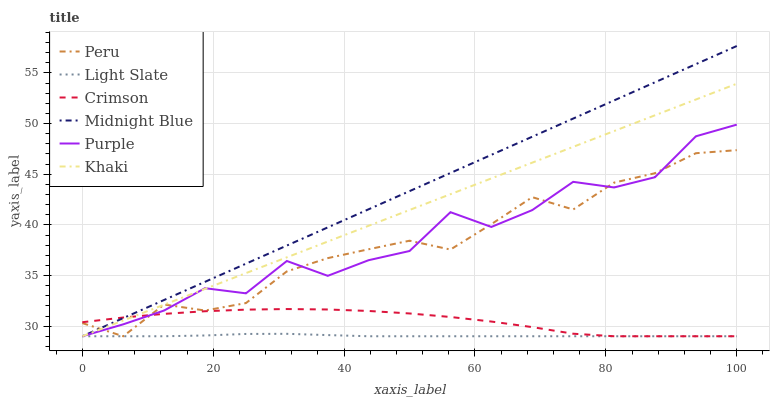Does Light Slate have the minimum area under the curve?
Answer yes or no. Yes. Does Midnight Blue have the maximum area under the curve?
Answer yes or no. Yes. Does Midnight Blue have the minimum area under the curve?
Answer yes or no. No. Does Light Slate have the maximum area under the curve?
Answer yes or no. No. Is Midnight Blue the smoothest?
Answer yes or no. Yes. Is Purple the roughest?
Answer yes or no. Yes. Is Light Slate the smoothest?
Answer yes or no. No. Is Light Slate the roughest?
Answer yes or no. No. Does Khaki have the lowest value?
Answer yes or no. Yes. Does Midnight Blue have the highest value?
Answer yes or no. Yes. Does Light Slate have the highest value?
Answer yes or no. No. Does Crimson intersect Khaki?
Answer yes or no. Yes. Is Crimson less than Khaki?
Answer yes or no. No. Is Crimson greater than Khaki?
Answer yes or no. No. 